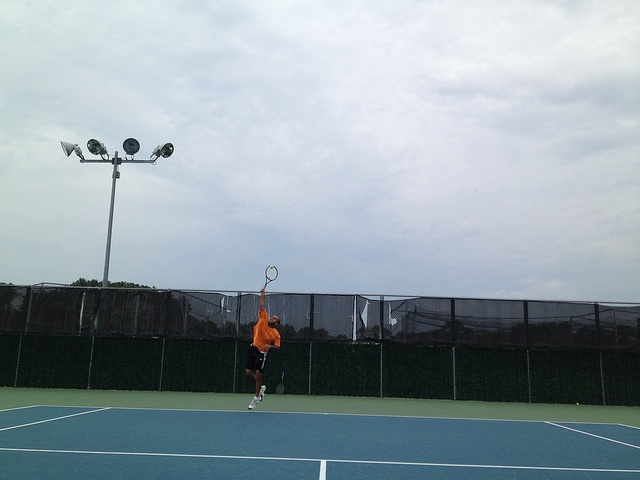Describe the objects in this image and their specific colors. I can see people in lightgray, black, brown, and maroon tones, tennis racket in lightgray, darkgray, gray, and lightblue tones, sports ball in lightgray and darkgreen tones, and sports ball in lightgray, lightgreen, green, and darkgreen tones in this image. 